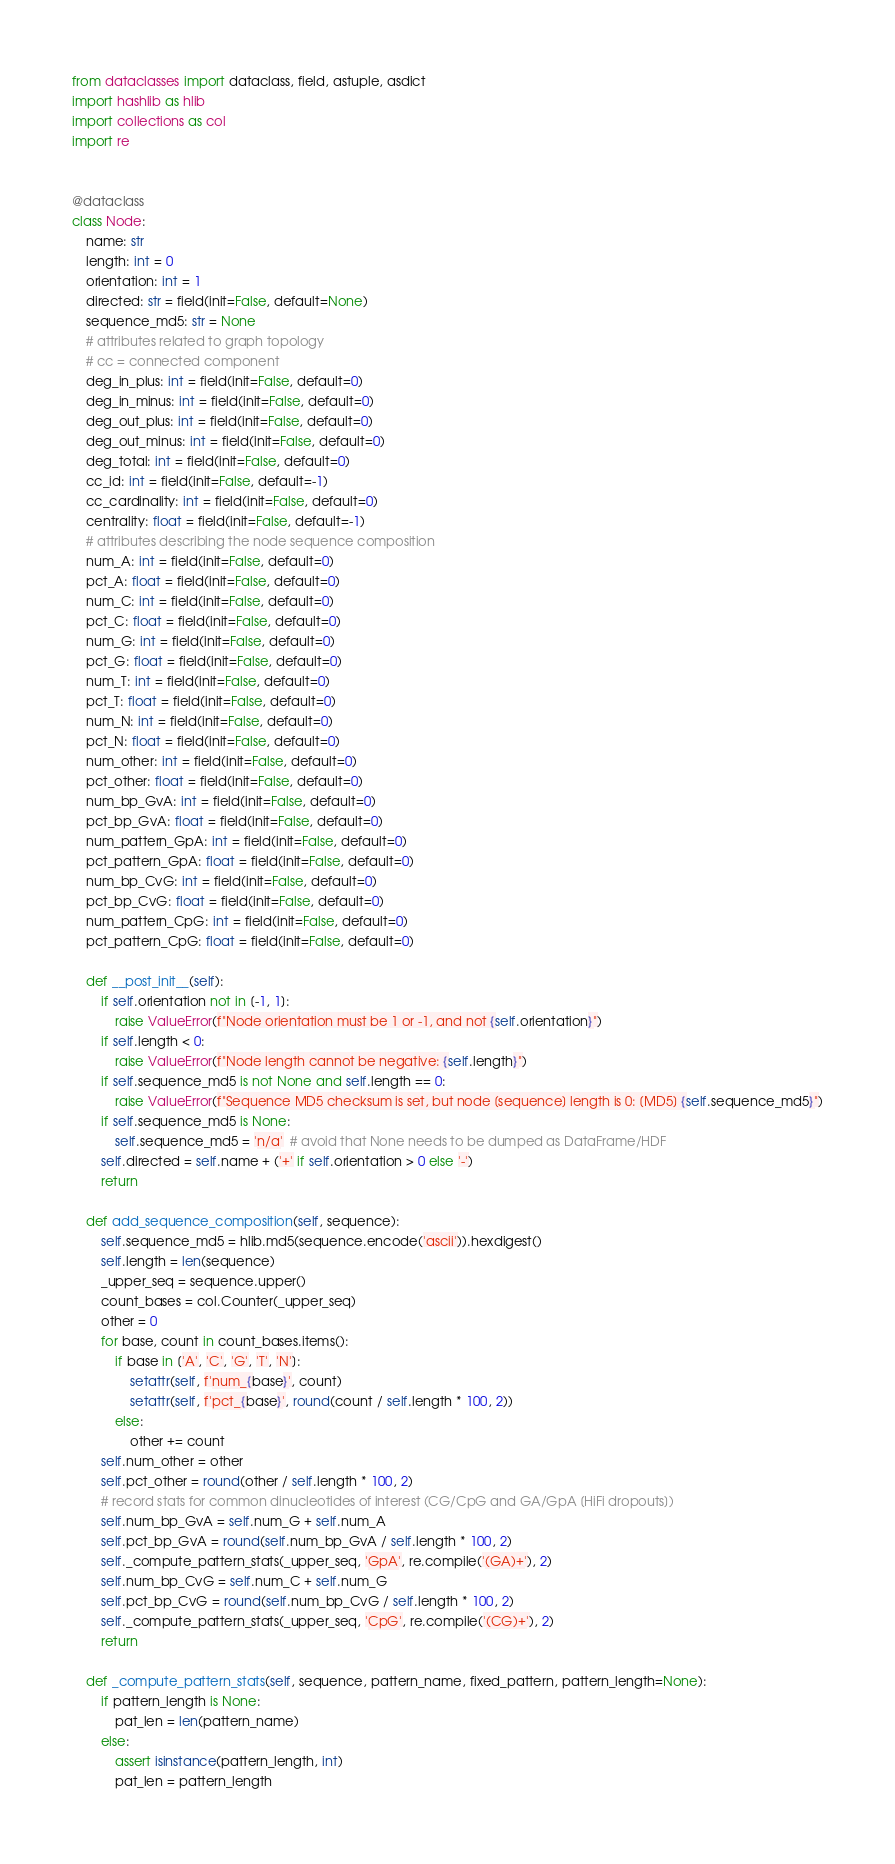<code> <loc_0><loc_0><loc_500><loc_500><_Python_>from dataclasses import dataclass, field, astuple, asdict
import hashlib as hlib
import collections as col
import re


@dataclass
class Node:
    name: str
    length: int = 0
    orientation: int = 1
    directed: str = field(init=False, default=None)
    sequence_md5: str = None
    # attributes related to graph topology
    # cc = connected component
    deg_in_plus: int = field(init=False, default=0)
    deg_in_minus: int = field(init=False, default=0)
    deg_out_plus: int = field(init=False, default=0)
    deg_out_minus: int = field(init=False, default=0)
    deg_total: int = field(init=False, default=0)
    cc_id: int = field(init=False, default=-1)
    cc_cardinality: int = field(init=False, default=0)
    centrality: float = field(init=False, default=-1)
    # attributes describing the node sequence composition
    num_A: int = field(init=False, default=0)
    pct_A: float = field(init=False, default=0)
    num_C: int = field(init=False, default=0)
    pct_C: float = field(init=False, default=0)
    num_G: int = field(init=False, default=0)
    pct_G: float = field(init=False, default=0)
    num_T: int = field(init=False, default=0)
    pct_T: float = field(init=False, default=0)
    num_N: int = field(init=False, default=0)
    pct_N: float = field(init=False, default=0)
    num_other: int = field(init=False, default=0)
    pct_other: float = field(init=False, default=0)
    num_bp_GvA: int = field(init=False, default=0)
    pct_bp_GvA: float = field(init=False, default=0)
    num_pattern_GpA: int = field(init=False, default=0)
    pct_pattern_GpA: float = field(init=False, default=0)
    num_bp_CvG: int = field(init=False, default=0)
    pct_bp_CvG: float = field(init=False, default=0)
    num_pattern_CpG: int = field(init=False, default=0)
    pct_pattern_CpG: float = field(init=False, default=0)

    def __post_init__(self):
        if self.orientation not in [-1, 1]:
            raise ValueError(f"Node orientation must be 1 or -1, and not {self.orientation}")
        if self.length < 0:
            raise ValueError(f"Node length cannot be negative: {self.length}")
        if self.sequence_md5 is not None and self.length == 0:
            raise ValueError(f"Sequence MD5 checksum is set, but node [sequence] length is 0: [MD5] {self.sequence_md5}")
        if self.sequence_md5 is None:
            self.sequence_md5 = 'n/a'  # avoid that None needs to be dumped as DataFrame/HDF
        self.directed = self.name + ('+' if self.orientation > 0 else '-')
        return

    def add_sequence_composition(self, sequence):
        self.sequence_md5 = hlib.md5(sequence.encode('ascii')).hexdigest()
        self.length = len(sequence)
        _upper_seq = sequence.upper()
        count_bases = col.Counter(_upper_seq)
        other = 0
        for base, count in count_bases.items():
            if base in ['A', 'C', 'G', 'T', 'N']:
                setattr(self, f'num_{base}', count)
                setattr(self, f'pct_{base}', round(count / self.length * 100, 2))
            else:
                other += count
        self.num_other = other
        self.pct_other = round(other / self.length * 100, 2)
        # record stats for common dinucleotides of interest (CG/CpG and GA/GpA [HiFi dropouts])
        self.num_bp_GvA = self.num_G + self.num_A
        self.pct_bp_GvA = round(self.num_bp_GvA / self.length * 100, 2)
        self._compute_pattern_stats(_upper_seq, 'GpA', re.compile('(GA)+'), 2)
        self.num_bp_CvG = self.num_C + self.num_G
        self.pct_bp_CvG = round(self.num_bp_CvG / self.length * 100, 2)
        self._compute_pattern_stats(_upper_seq, 'CpG', re.compile('(CG)+'), 2)
        return

    def _compute_pattern_stats(self, sequence, pattern_name, fixed_pattern, pattern_length=None):
        if pattern_length is None:
            pat_len = len(pattern_name)
        else:
            assert isinstance(pattern_length, int)
            pat_len = pattern_length</code> 